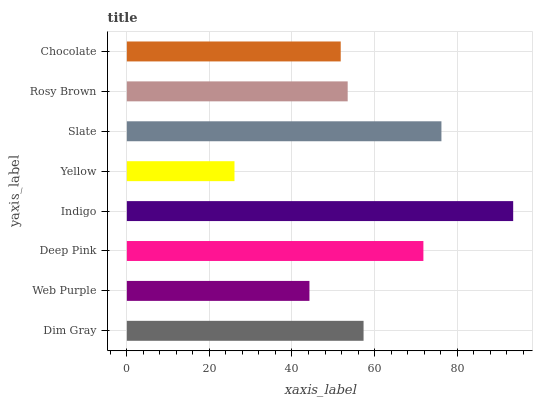Is Yellow the minimum?
Answer yes or no. Yes. Is Indigo the maximum?
Answer yes or no. Yes. Is Web Purple the minimum?
Answer yes or no. No. Is Web Purple the maximum?
Answer yes or no. No. Is Dim Gray greater than Web Purple?
Answer yes or no. Yes. Is Web Purple less than Dim Gray?
Answer yes or no. Yes. Is Web Purple greater than Dim Gray?
Answer yes or no. No. Is Dim Gray less than Web Purple?
Answer yes or no. No. Is Dim Gray the high median?
Answer yes or no. Yes. Is Rosy Brown the low median?
Answer yes or no. Yes. Is Indigo the high median?
Answer yes or no. No. Is Yellow the low median?
Answer yes or no. No. 